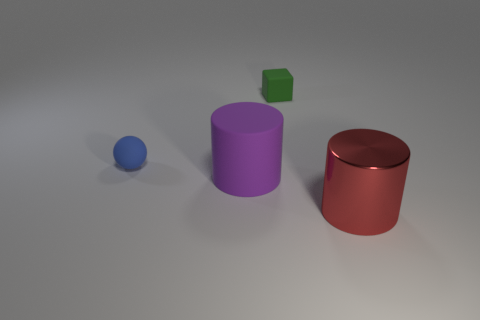Add 2 metallic objects. How many objects exist? 6 Subtract all blocks. How many objects are left? 3 Subtract all tiny red shiny cubes. Subtract all rubber balls. How many objects are left? 3 Add 1 big shiny things. How many big shiny things are left? 2 Add 2 small green rubber spheres. How many small green rubber spheres exist? 2 Subtract 0 gray balls. How many objects are left? 4 